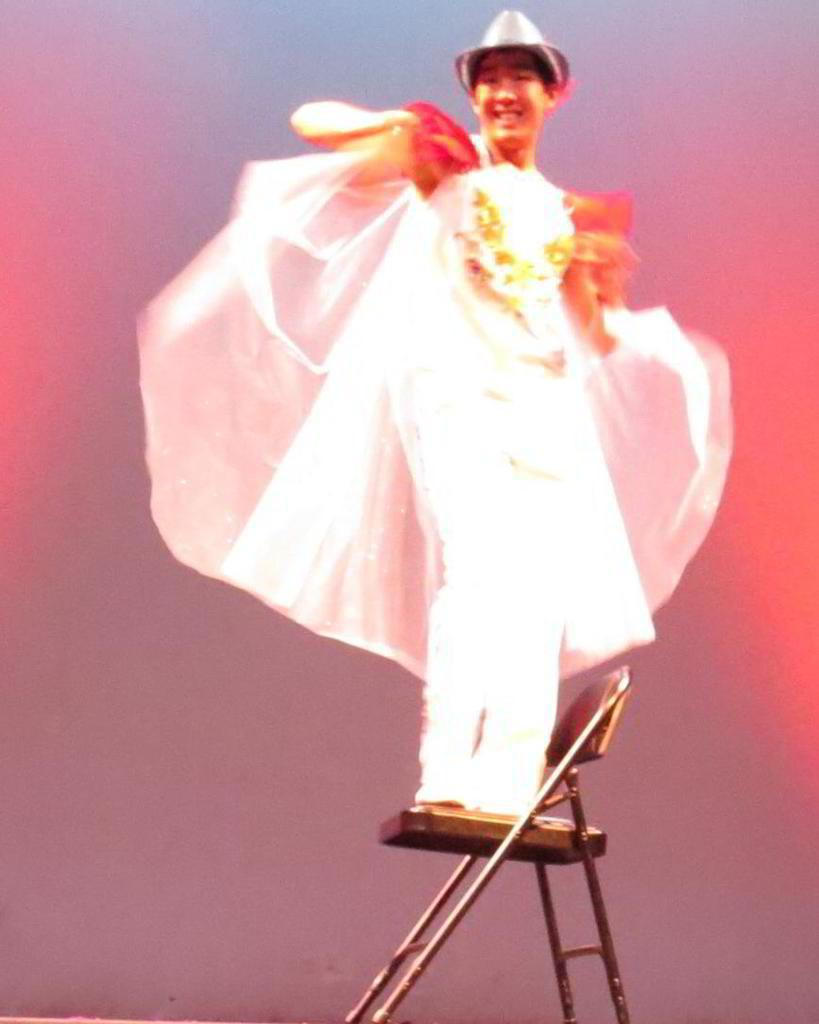What is the main subject of the image? There is a person in the image. What is the person doing in the image? The person is standing on a chair. What is the person wearing in the image? The person is wearing a white dress. Where is the person located in the image? The person is located in the middle of the image. What book is the person holding in the image? There is no book present in the image. What type of star can be seen in the image? There is no star visible in the image. 